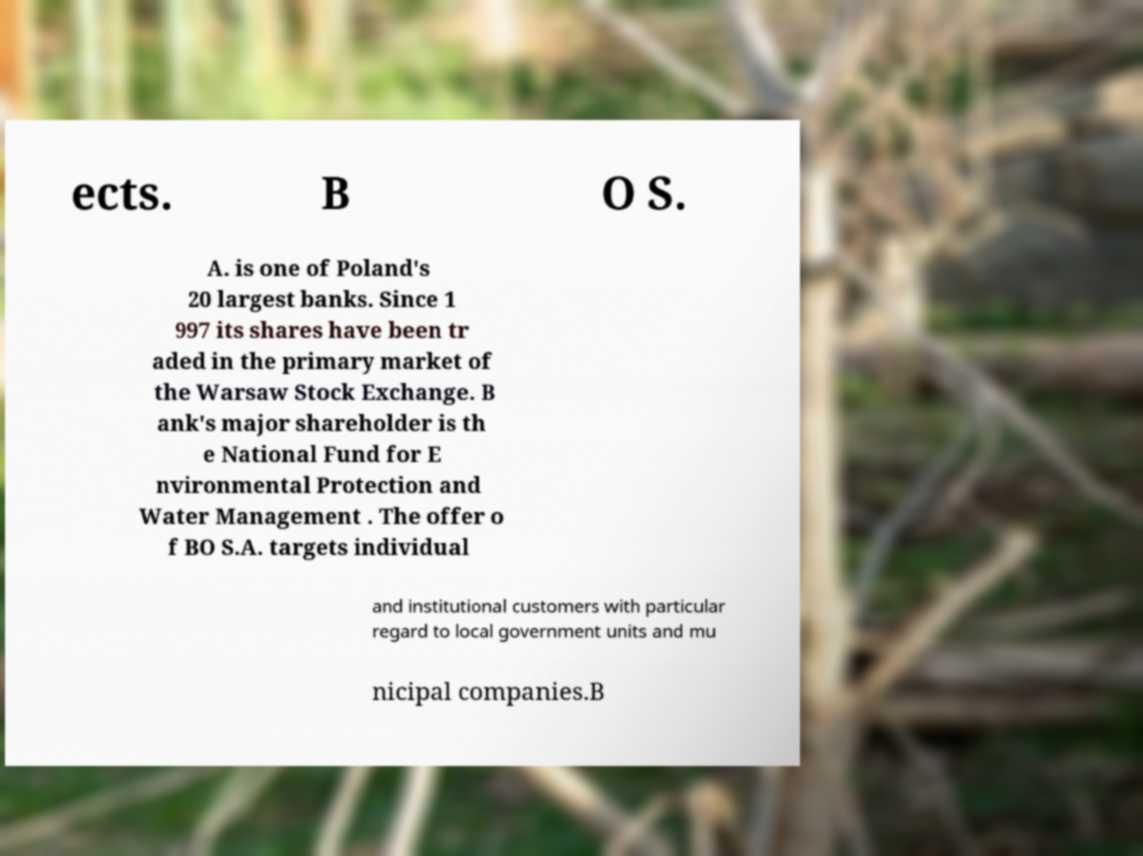Please identify and transcribe the text found in this image. ects. B O S. A. is one of Poland's 20 largest banks. Since 1 997 its shares have been tr aded in the primary market of the Warsaw Stock Exchange. B ank's major shareholder is th e National Fund for E nvironmental Protection and Water Management . The offer o f BO S.A. targets individual and institutional customers with particular regard to local government units and mu nicipal companies.B 